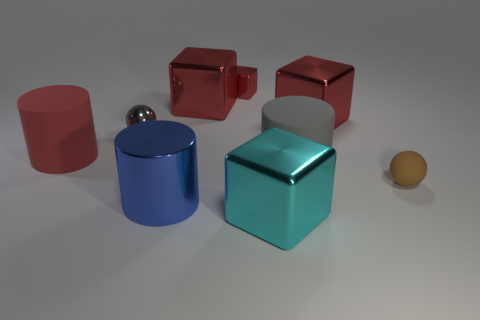How many red cubes must be subtracted to get 1 red cubes? 2 Subtract all big blue metallic cylinders. How many cylinders are left? 2 Subtract all cyan balls. How many red cubes are left? 3 Subtract all gray cylinders. How many cylinders are left? 2 Subtract 0 blue spheres. How many objects are left? 9 Subtract all balls. How many objects are left? 7 Subtract 2 cylinders. How many cylinders are left? 1 Subtract all green cylinders. Subtract all gray blocks. How many cylinders are left? 3 Subtract all matte things. Subtract all red rubber cylinders. How many objects are left? 5 Add 9 brown rubber balls. How many brown rubber balls are left? 10 